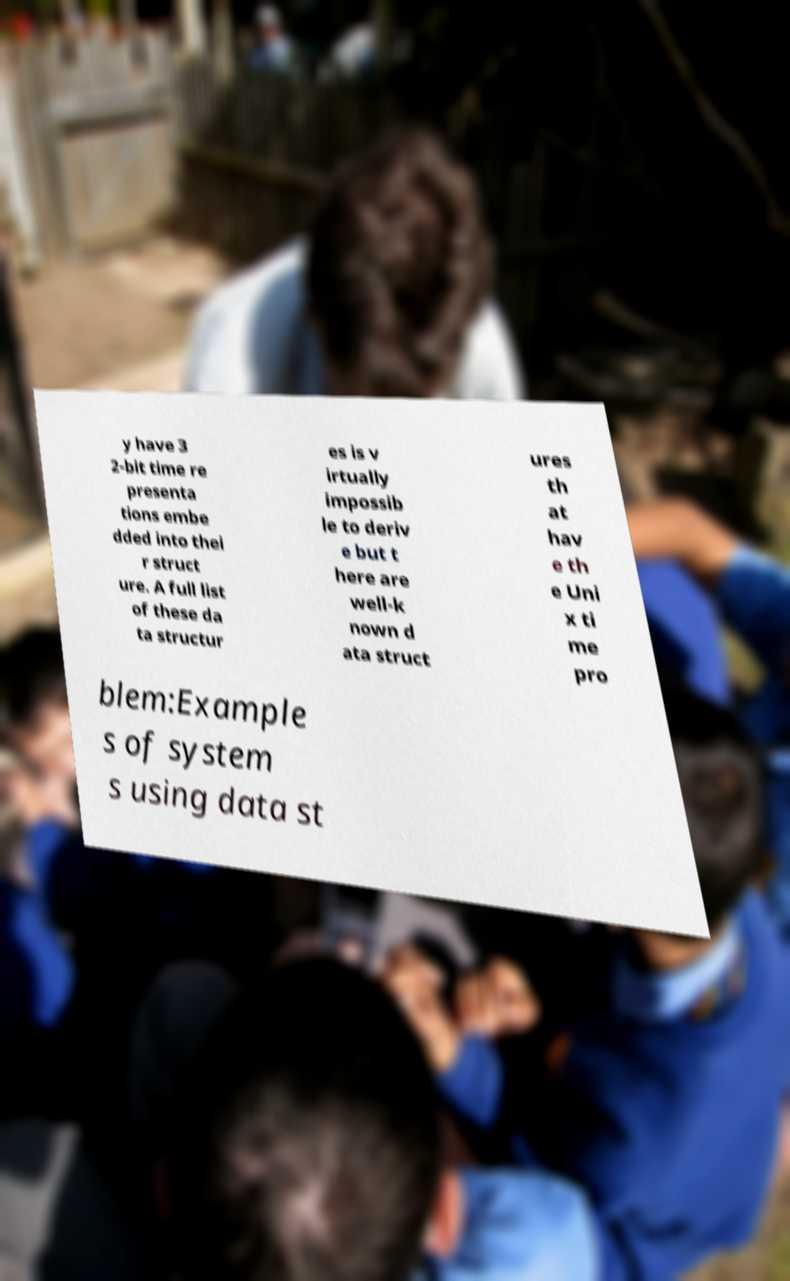Please identify and transcribe the text found in this image. y have 3 2-bit time re presenta tions embe dded into thei r struct ure. A full list of these da ta structur es is v irtually impossib le to deriv e but t here are well-k nown d ata struct ures th at hav e th e Uni x ti me pro blem:Example s of system s using data st 